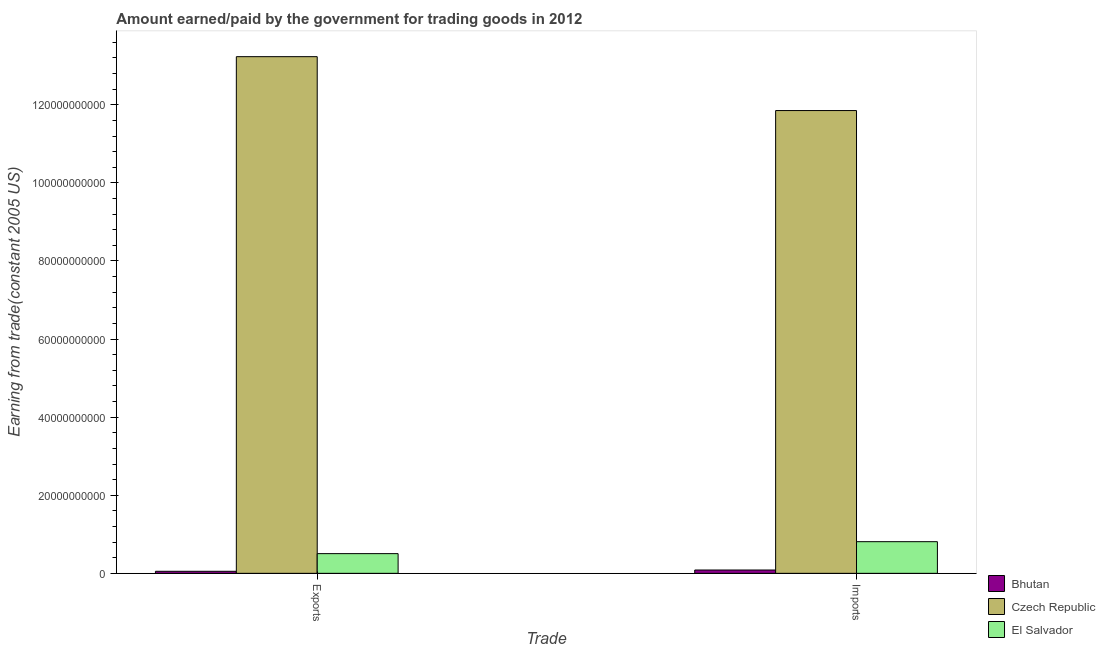How many different coloured bars are there?
Ensure brevity in your answer.  3. Are the number of bars on each tick of the X-axis equal?
Offer a very short reply. Yes. How many bars are there on the 2nd tick from the right?
Give a very brief answer. 3. What is the label of the 1st group of bars from the left?
Give a very brief answer. Exports. What is the amount earned from exports in El Salvador?
Make the answer very short. 5.04e+09. Across all countries, what is the maximum amount earned from exports?
Make the answer very short. 1.32e+11. Across all countries, what is the minimum amount paid for imports?
Ensure brevity in your answer.  8.53e+08. In which country was the amount paid for imports maximum?
Keep it short and to the point. Czech Republic. In which country was the amount paid for imports minimum?
Your answer should be compact. Bhutan. What is the total amount earned from exports in the graph?
Your answer should be compact. 1.38e+11. What is the difference between the amount paid for imports in El Salvador and that in Bhutan?
Your answer should be compact. 7.25e+09. What is the difference between the amount paid for imports in Czech Republic and the amount earned from exports in Bhutan?
Keep it short and to the point. 1.18e+11. What is the average amount paid for imports per country?
Offer a terse response. 4.25e+1. What is the difference between the amount earned from exports and amount paid for imports in Czech Republic?
Provide a short and direct response. 1.38e+1. What is the ratio of the amount earned from exports in El Salvador to that in Bhutan?
Give a very brief answer. 9.62. Is the amount earned from exports in Czech Republic less than that in Bhutan?
Your answer should be very brief. No. What does the 3rd bar from the left in Exports represents?
Ensure brevity in your answer.  El Salvador. What does the 2nd bar from the right in Exports represents?
Keep it short and to the point. Czech Republic. How many bars are there?
Offer a terse response. 6. What is the difference between two consecutive major ticks on the Y-axis?
Offer a terse response. 2.00e+1. Are the values on the major ticks of Y-axis written in scientific E-notation?
Give a very brief answer. No. Does the graph contain any zero values?
Provide a succinct answer. No. Does the graph contain grids?
Ensure brevity in your answer.  No. How many legend labels are there?
Provide a short and direct response. 3. What is the title of the graph?
Ensure brevity in your answer.  Amount earned/paid by the government for trading goods in 2012. Does "Guam" appear as one of the legend labels in the graph?
Offer a very short reply. No. What is the label or title of the X-axis?
Your response must be concise. Trade. What is the label or title of the Y-axis?
Offer a very short reply. Earning from trade(constant 2005 US). What is the Earning from trade(constant 2005 US) of Bhutan in Exports?
Keep it short and to the point. 5.24e+08. What is the Earning from trade(constant 2005 US) in Czech Republic in Exports?
Keep it short and to the point. 1.32e+11. What is the Earning from trade(constant 2005 US) of El Salvador in Exports?
Offer a terse response. 5.04e+09. What is the Earning from trade(constant 2005 US) of Bhutan in Imports?
Make the answer very short. 8.53e+08. What is the Earning from trade(constant 2005 US) of Czech Republic in Imports?
Make the answer very short. 1.19e+11. What is the Earning from trade(constant 2005 US) of El Salvador in Imports?
Your response must be concise. 8.11e+09. Across all Trade, what is the maximum Earning from trade(constant 2005 US) of Bhutan?
Provide a short and direct response. 8.53e+08. Across all Trade, what is the maximum Earning from trade(constant 2005 US) of Czech Republic?
Keep it short and to the point. 1.32e+11. Across all Trade, what is the maximum Earning from trade(constant 2005 US) of El Salvador?
Your answer should be very brief. 8.11e+09. Across all Trade, what is the minimum Earning from trade(constant 2005 US) in Bhutan?
Offer a terse response. 5.24e+08. Across all Trade, what is the minimum Earning from trade(constant 2005 US) in Czech Republic?
Your answer should be compact. 1.19e+11. Across all Trade, what is the minimum Earning from trade(constant 2005 US) in El Salvador?
Provide a succinct answer. 5.04e+09. What is the total Earning from trade(constant 2005 US) in Bhutan in the graph?
Make the answer very short. 1.38e+09. What is the total Earning from trade(constant 2005 US) in Czech Republic in the graph?
Make the answer very short. 2.51e+11. What is the total Earning from trade(constant 2005 US) of El Salvador in the graph?
Offer a very short reply. 1.32e+1. What is the difference between the Earning from trade(constant 2005 US) in Bhutan in Exports and that in Imports?
Provide a succinct answer. -3.29e+08. What is the difference between the Earning from trade(constant 2005 US) in Czech Republic in Exports and that in Imports?
Provide a short and direct response. 1.38e+1. What is the difference between the Earning from trade(constant 2005 US) of El Salvador in Exports and that in Imports?
Your response must be concise. -3.06e+09. What is the difference between the Earning from trade(constant 2005 US) in Bhutan in Exports and the Earning from trade(constant 2005 US) in Czech Republic in Imports?
Offer a terse response. -1.18e+11. What is the difference between the Earning from trade(constant 2005 US) in Bhutan in Exports and the Earning from trade(constant 2005 US) in El Salvador in Imports?
Give a very brief answer. -7.58e+09. What is the difference between the Earning from trade(constant 2005 US) in Czech Republic in Exports and the Earning from trade(constant 2005 US) in El Salvador in Imports?
Your answer should be very brief. 1.24e+11. What is the average Earning from trade(constant 2005 US) in Bhutan per Trade?
Make the answer very short. 6.89e+08. What is the average Earning from trade(constant 2005 US) of Czech Republic per Trade?
Provide a succinct answer. 1.25e+11. What is the average Earning from trade(constant 2005 US) of El Salvador per Trade?
Make the answer very short. 6.58e+09. What is the difference between the Earning from trade(constant 2005 US) in Bhutan and Earning from trade(constant 2005 US) in Czech Republic in Exports?
Ensure brevity in your answer.  -1.32e+11. What is the difference between the Earning from trade(constant 2005 US) in Bhutan and Earning from trade(constant 2005 US) in El Salvador in Exports?
Your response must be concise. -4.52e+09. What is the difference between the Earning from trade(constant 2005 US) of Czech Republic and Earning from trade(constant 2005 US) of El Salvador in Exports?
Your answer should be compact. 1.27e+11. What is the difference between the Earning from trade(constant 2005 US) of Bhutan and Earning from trade(constant 2005 US) of Czech Republic in Imports?
Keep it short and to the point. -1.18e+11. What is the difference between the Earning from trade(constant 2005 US) of Bhutan and Earning from trade(constant 2005 US) of El Salvador in Imports?
Your answer should be very brief. -7.25e+09. What is the difference between the Earning from trade(constant 2005 US) in Czech Republic and Earning from trade(constant 2005 US) in El Salvador in Imports?
Your answer should be very brief. 1.10e+11. What is the ratio of the Earning from trade(constant 2005 US) in Bhutan in Exports to that in Imports?
Keep it short and to the point. 0.61. What is the ratio of the Earning from trade(constant 2005 US) in Czech Republic in Exports to that in Imports?
Make the answer very short. 1.12. What is the ratio of the Earning from trade(constant 2005 US) in El Salvador in Exports to that in Imports?
Offer a very short reply. 0.62. What is the difference between the highest and the second highest Earning from trade(constant 2005 US) of Bhutan?
Your answer should be very brief. 3.29e+08. What is the difference between the highest and the second highest Earning from trade(constant 2005 US) of Czech Republic?
Your answer should be very brief. 1.38e+1. What is the difference between the highest and the second highest Earning from trade(constant 2005 US) in El Salvador?
Give a very brief answer. 3.06e+09. What is the difference between the highest and the lowest Earning from trade(constant 2005 US) of Bhutan?
Your answer should be compact. 3.29e+08. What is the difference between the highest and the lowest Earning from trade(constant 2005 US) of Czech Republic?
Your response must be concise. 1.38e+1. What is the difference between the highest and the lowest Earning from trade(constant 2005 US) of El Salvador?
Provide a succinct answer. 3.06e+09. 